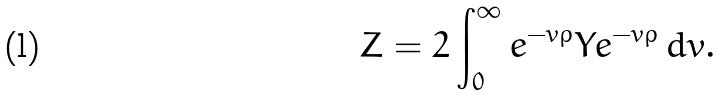<formula> <loc_0><loc_0><loc_500><loc_500>Z = 2 \int _ { 0 } ^ { \infty } e ^ { - v \rho } Y e ^ { - v \rho } \, d v .</formula> 